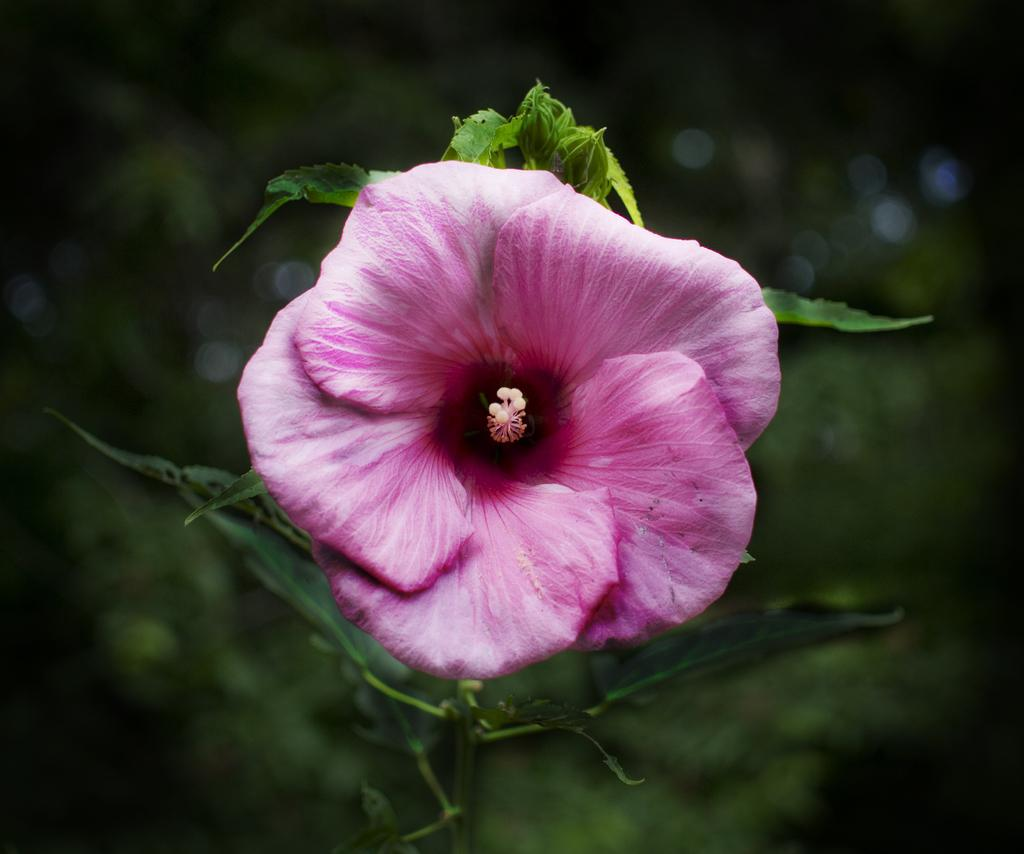What is the main subject of the image? There is a beautiful flower in the image. What color is the background of the flower? The background of the flower is blue. What type of business is being conducted in the image? There is no indication of any business activity in the image, as it features a beautiful flower with a blue background. How many bananas can be seen in the image? There are no bananas present in the image. 